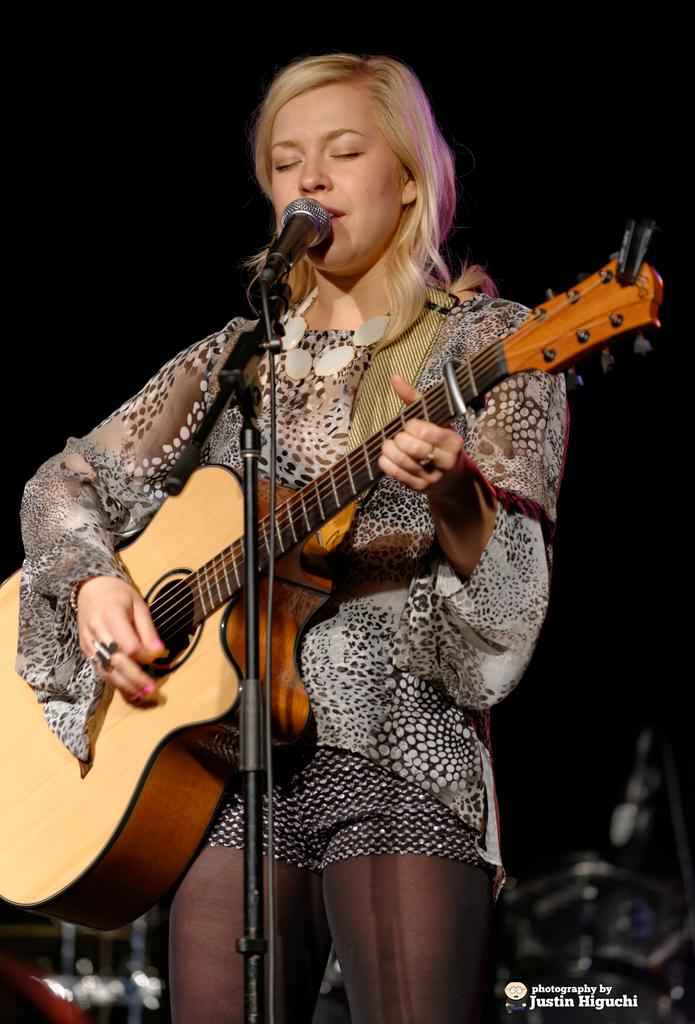Who is the main subject in the image? There is a woman in the image. What is the woman holding in the image? The woman is holding a guitar. What is the woman doing with the guitar? The woman is playing the guitar. What other object is present in the image? There is a microphone in the image. What might the woman be doing with the microphone? The woman is likely singing through the microphone. How many chairs are visible in the image? There are no chairs visible in the image. What type of noise can be heard coming from the guitar in the image? The image is a still image, so no sound or noise can be heard from the guitar. 